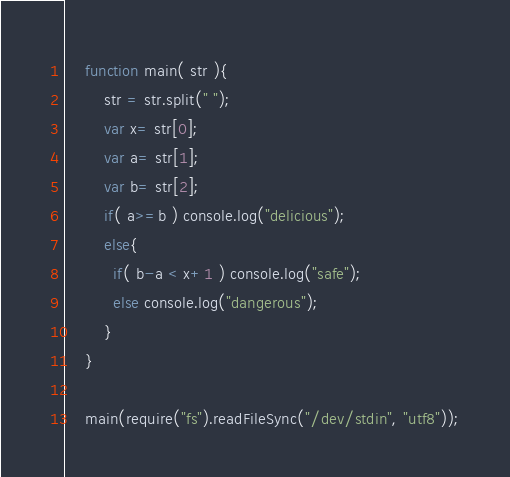Convert code to text. <code><loc_0><loc_0><loc_500><loc_500><_JavaScript_>    function main( str ){
    	str = str.split(" ");
    	var x= str[0];
    	var a= str[1];
    	var b= str[2];
    	if( a>=b ) console.log("delicious");
    	else{
          if( b-a < x+1 ) console.log("safe");
          else console.log("dangerous");
        }
    }
     
    main(require("fs").readFileSync("/dev/stdin", "utf8"));</code> 